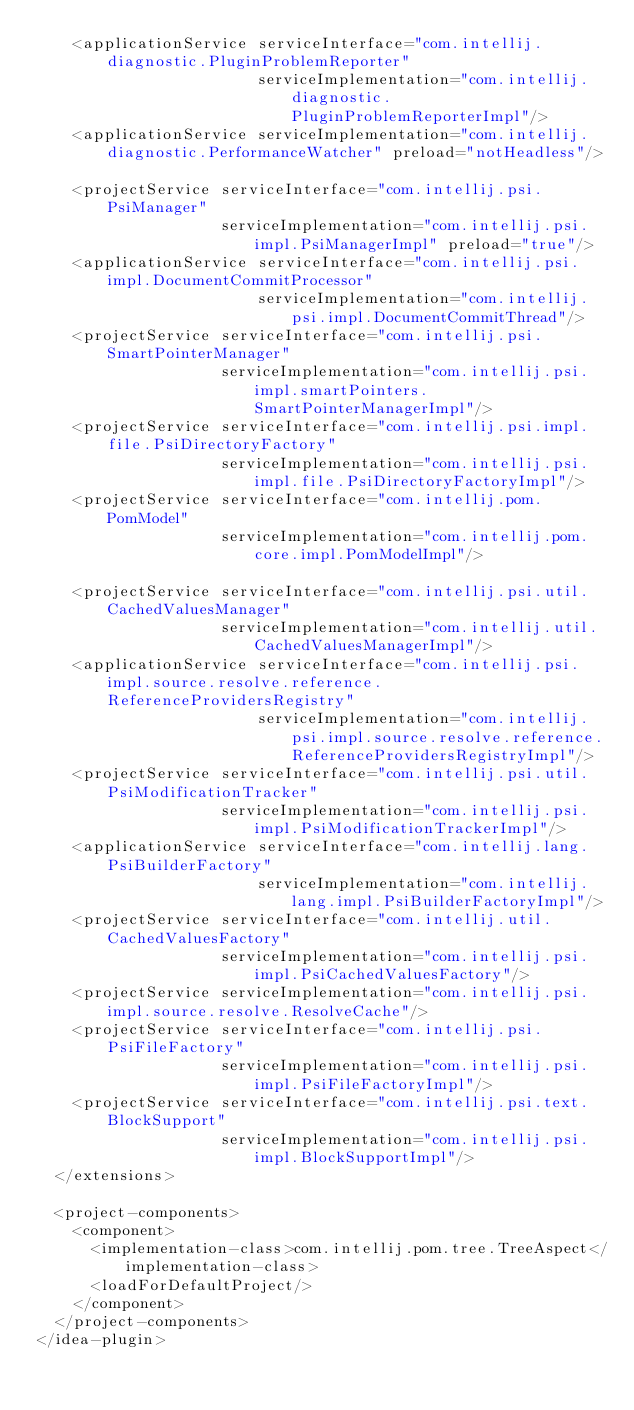Convert code to text. <code><loc_0><loc_0><loc_500><loc_500><_XML_>    <applicationService serviceInterface="com.intellij.diagnostic.PluginProblemReporter"
                        serviceImplementation="com.intellij.diagnostic.PluginProblemReporterImpl"/>
    <applicationService serviceImplementation="com.intellij.diagnostic.PerformanceWatcher" preload="notHeadless"/>

    <projectService serviceInterface="com.intellij.psi.PsiManager"
                    serviceImplementation="com.intellij.psi.impl.PsiManagerImpl" preload="true"/>
    <applicationService serviceInterface="com.intellij.psi.impl.DocumentCommitProcessor"
                        serviceImplementation="com.intellij.psi.impl.DocumentCommitThread"/>
    <projectService serviceInterface="com.intellij.psi.SmartPointerManager"
                    serviceImplementation="com.intellij.psi.impl.smartPointers.SmartPointerManagerImpl"/>
    <projectService serviceInterface="com.intellij.psi.impl.file.PsiDirectoryFactory"
                    serviceImplementation="com.intellij.psi.impl.file.PsiDirectoryFactoryImpl"/>
    <projectService serviceInterface="com.intellij.pom.PomModel"
                    serviceImplementation="com.intellij.pom.core.impl.PomModelImpl"/>

    <projectService serviceInterface="com.intellij.psi.util.CachedValuesManager"
                    serviceImplementation="com.intellij.util.CachedValuesManagerImpl"/>
    <applicationService serviceInterface="com.intellij.psi.impl.source.resolve.reference.ReferenceProvidersRegistry"
                        serviceImplementation="com.intellij.psi.impl.source.resolve.reference.ReferenceProvidersRegistryImpl"/>
    <projectService serviceInterface="com.intellij.psi.util.PsiModificationTracker"
                    serviceImplementation="com.intellij.psi.impl.PsiModificationTrackerImpl"/>
    <applicationService serviceInterface="com.intellij.lang.PsiBuilderFactory"
                        serviceImplementation="com.intellij.lang.impl.PsiBuilderFactoryImpl"/>
    <projectService serviceInterface="com.intellij.util.CachedValuesFactory"
                    serviceImplementation="com.intellij.psi.impl.PsiCachedValuesFactory"/>
    <projectService serviceImplementation="com.intellij.psi.impl.source.resolve.ResolveCache"/>
    <projectService serviceInterface="com.intellij.psi.PsiFileFactory"
                    serviceImplementation="com.intellij.psi.impl.PsiFileFactoryImpl"/>
    <projectService serviceInterface="com.intellij.psi.text.BlockSupport"
                    serviceImplementation="com.intellij.psi.impl.BlockSupportImpl"/>
  </extensions>

  <project-components>
    <component>
      <implementation-class>com.intellij.pom.tree.TreeAspect</implementation-class>
      <loadForDefaultProject/>
    </component>
  </project-components>
</idea-plugin>
</code> 